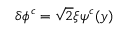<formula> <loc_0><loc_0><loc_500><loc_500>\delta \phi ^ { c } = \sqrt { 2 } \xi \psi ^ { c } ( y ) \,</formula> 